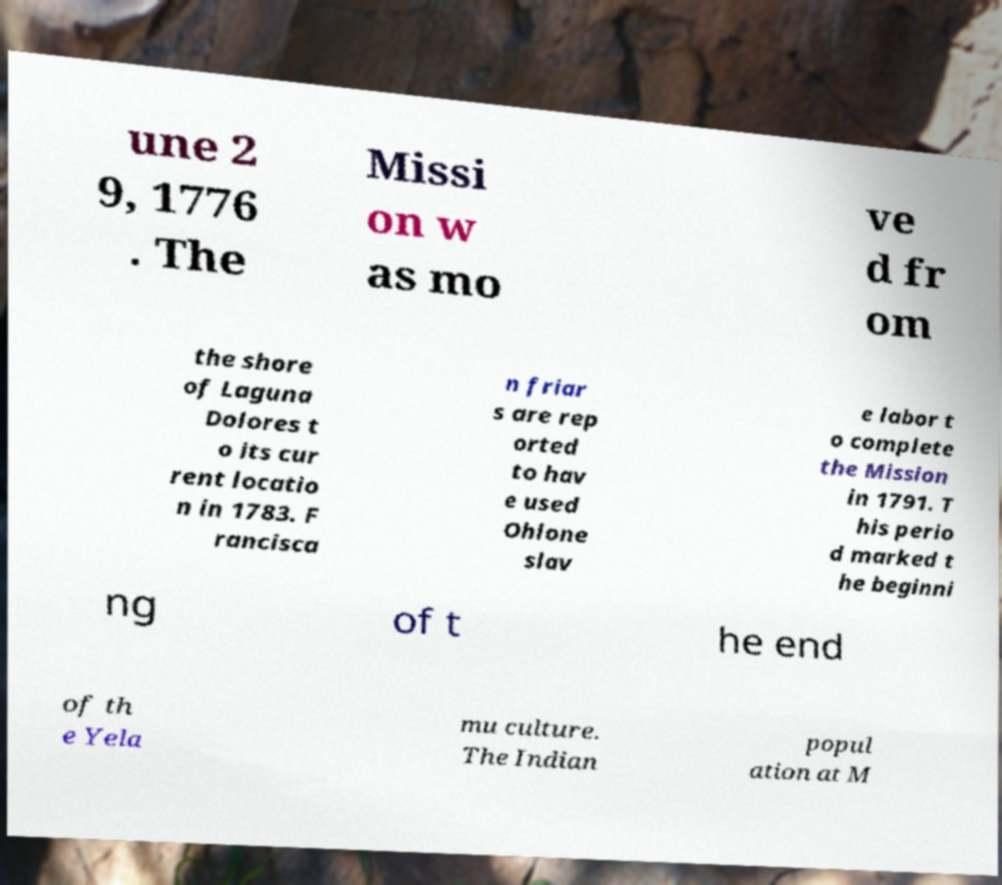For documentation purposes, I need the text within this image transcribed. Could you provide that? une 2 9, 1776 . The Missi on w as mo ve d fr om the shore of Laguna Dolores t o its cur rent locatio n in 1783. F rancisca n friar s are rep orted to hav e used Ohlone slav e labor t o complete the Mission in 1791. T his perio d marked t he beginni ng of t he end of th e Yela mu culture. The Indian popul ation at M 